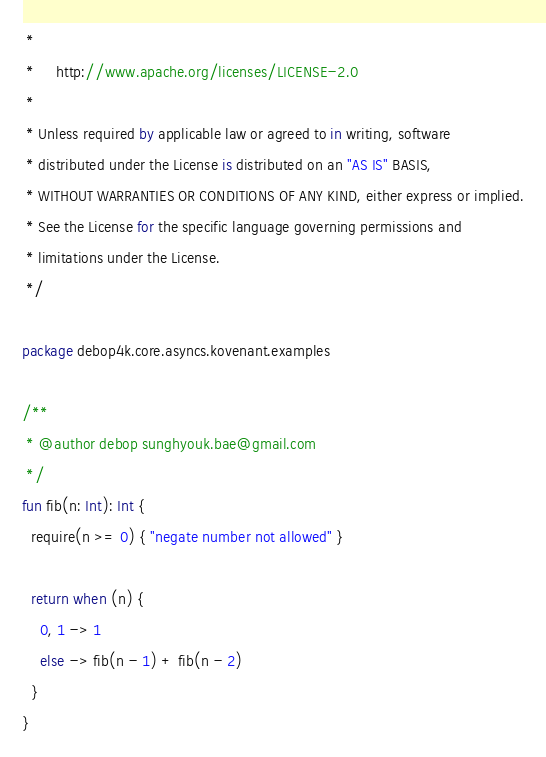Convert code to text. <code><loc_0><loc_0><loc_500><loc_500><_Kotlin_> *
 *     http://www.apache.org/licenses/LICENSE-2.0
 *
 * Unless required by applicable law or agreed to in writing, software
 * distributed under the License is distributed on an "AS IS" BASIS,
 * WITHOUT WARRANTIES OR CONDITIONS OF ANY KIND, either express or implied.
 * See the License for the specific language governing permissions and
 * limitations under the License.
 */

package debop4k.core.asyncs.kovenant.examples

/**
 * @author debop sunghyouk.bae@gmail.com
 */
fun fib(n: Int): Int {
  require(n >= 0) { "negate number not allowed" }

  return when (n) {
    0, 1 -> 1
    else -> fib(n - 1) + fib(n - 2)
  }
}</code> 